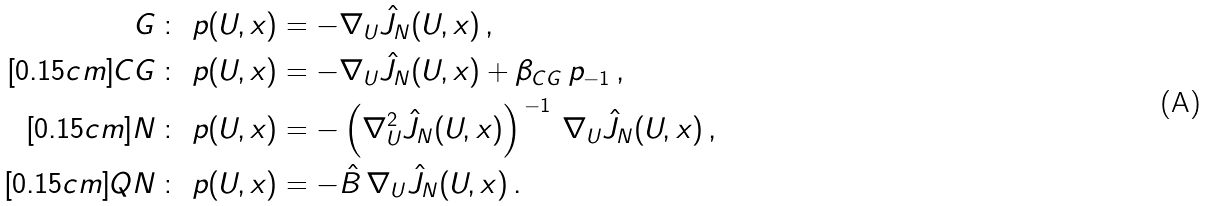Convert formula to latex. <formula><loc_0><loc_0><loc_500><loc_500>G \, \colon \ p ( U , x ) & = - \nabla _ { U } \hat { J } _ { N } ( U , x ) \, , \\ [ 0 . 1 5 c m ] C G \, \colon \ p ( U , x ) & = - \nabla _ { U } \hat { J } _ { N } ( U , x ) + \beta _ { C G } \, p _ { - 1 } \, , \\ [ 0 . 1 5 c m ] N \, \colon \ p ( U , x ) & = - \left ( \nabla ^ { 2 } _ { U } \hat { J } _ { N } ( U , x ) \right ) ^ { \, - 1 } \, \nabla _ { U } \hat { J } _ { N } ( U , x ) \, , \\ [ 0 . 1 5 c m ] Q N \, \colon \ p ( U , x ) & = - \hat { B } \, \nabla _ { U } \hat { J } _ { N } ( U , x ) \, .</formula> 